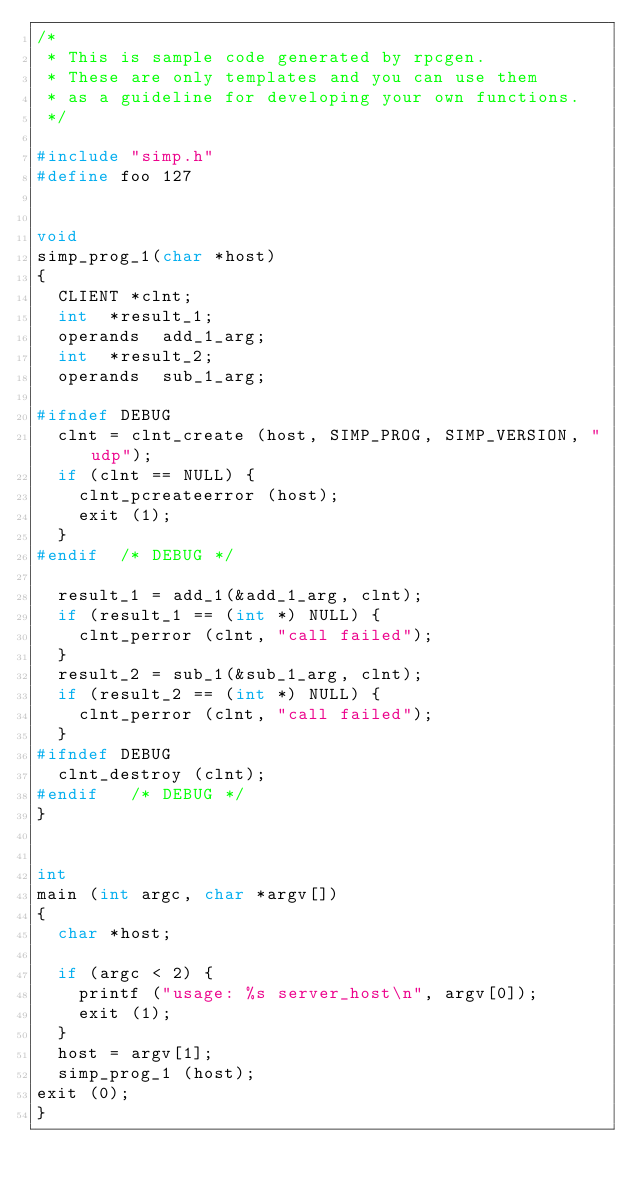<code> <loc_0><loc_0><loc_500><loc_500><_C_>/*
 * This is sample code generated by rpcgen.
 * These are only templates and you can use them
 * as a guideline for developing your own functions.
 */

#include "simp.h"
#define foo 127


void
simp_prog_1(char *host)
{
	CLIENT *clnt;
	int  *result_1;
	operands  add_1_arg;
	int  *result_2;
	operands  sub_1_arg;

#ifndef	DEBUG
	clnt = clnt_create (host, SIMP_PROG, SIMP_VERSION, "udp");
	if (clnt == NULL) {
		clnt_pcreateerror (host);
		exit (1);
	}
#endif	/* DEBUG */

	result_1 = add_1(&add_1_arg, clnt);
	if (result_1 == (int *) NULL) {
		clnt_perror (clnt, "call failed");
	}
	result_2 = sub_1(&sub_1_arg, clnt);
	if (result_2 == (int *) NULL) {
		clnt_perror (clnt, "call failed");
	}
#ifndef	DEBUG
	clnt_destroy (clnt);
#endif	 /* DEBUG */
}


int
main (int argc, char *argv[])
{
	char *host;

	if (argc < 2) {
		printf ("usage: %s server_host\n", argv[0]);
		exit (1);
	}
	host = argv[1];
	simp_prog_1 (host);
exit (0);
}
</code> 